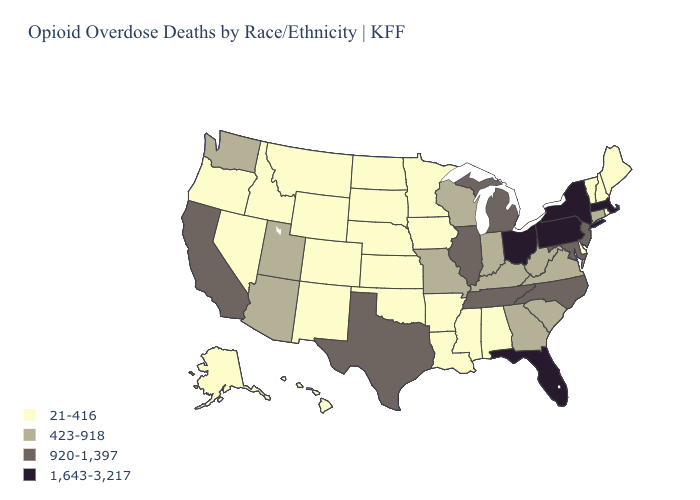Does Florida have the highest value in the South?
Be succinct. Yes. Among the states that border Illinois , which have the lowest value?
Quick response, please. Iowa. What is the value of North Carolina?
Short answer required. 920-1,397. What is the value of Utah?
Keep it brief. 423-918. What is the lowest value in the USA?
Write a very short answer. 21-416. Which states have the lowest value in the West?
Quick response, please. Alaska, Colorado, Hawaii, Idaho, Montana, Nevada, New Mexico, Oregon, Wyoming. Name the states that have a value in the range 21-416?
Answer briefly. Alabama, Alaska, Arkansas, Colorado, Delaware, Hawaii, Idaho, Iowa, Kansas, Louisiana, Maine, Minnesota, Mississippi, Montana, Nebraska, Nevada, New Hampshire, New Mexico, North Dakota, Oklahoma, Oregon, Rhode Island, South Dakota, Vermont, Wyoming. Does Ohio have the highest value in the USA?
Be succinct. Yes. What is the value of West Virginia?
Quick response, please. 423-918. Which states hav the highest value in the West?
Short answer required. California. What is the lowest value in the USA?
Write a very short answer. 21-416. What is the value of Oklahoma?
Quick response, please. 21-416. Name the states that have a value in the range 920-1,397?
Quick response, please. California, Illinois, Maryland, Michigan, New Jersey, North Carolina, Tennessee, Texas. What is the value of Iowa?
Answer briefly. 21-416. What is the value of Wyoming?
Keep it brief. 21-416. 